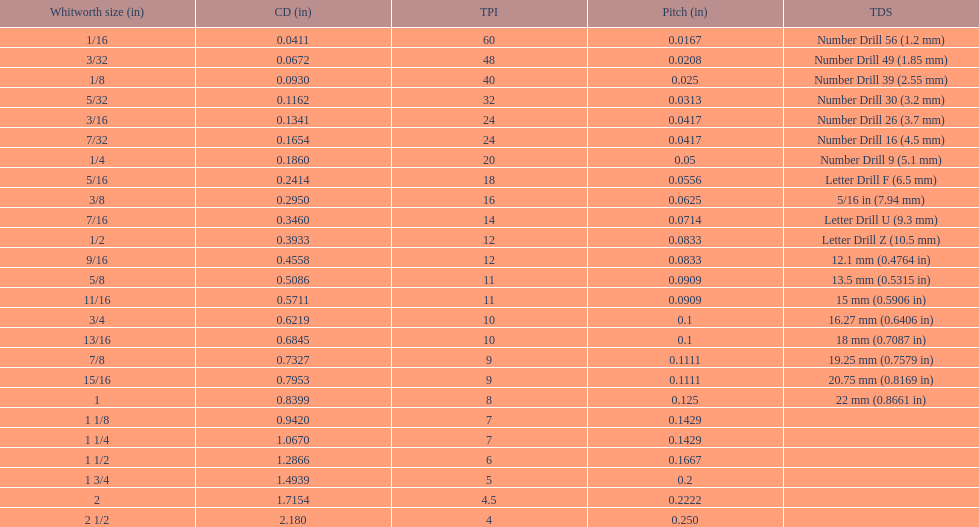What core diameter (in) comes after 0.0930? 0.1162. 